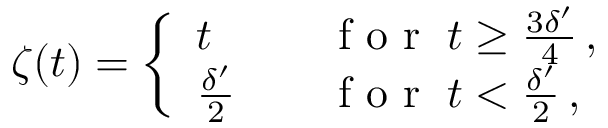<formula> <loc_0><loc_0><loc_500><loc_500>\zeta ( t ) = \left \{ \begin{array} { l l } { t } & { \quad f o r \, t \geq \frac { 3 \delta ^ { \prime } } { 4 } \, , } \\ { \frac { \delta ^ { \prime } } { 2 } } & { \quad f o r \, t < \frac { \delta ^ { \prime } } { 2 } \, , } \end{array}</formula> 